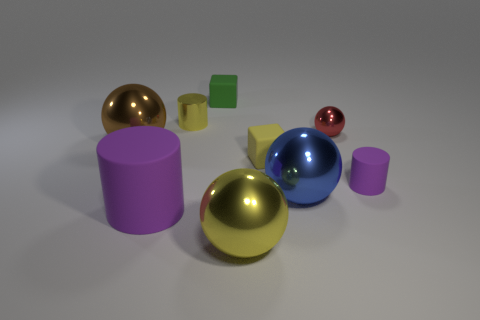Subtract all blocks. How many objects are left? 7 Add 3 tiny yellow things. How many tiny yellow things are left? 5 Add 2 red metallic balls. How many red metallic balls exist? 3 Subtract 1 yellow blocks. How many objects are left? 8 Subtract all blue objects. Subtract all big green rubber cylinders. How many objects are left? 8 